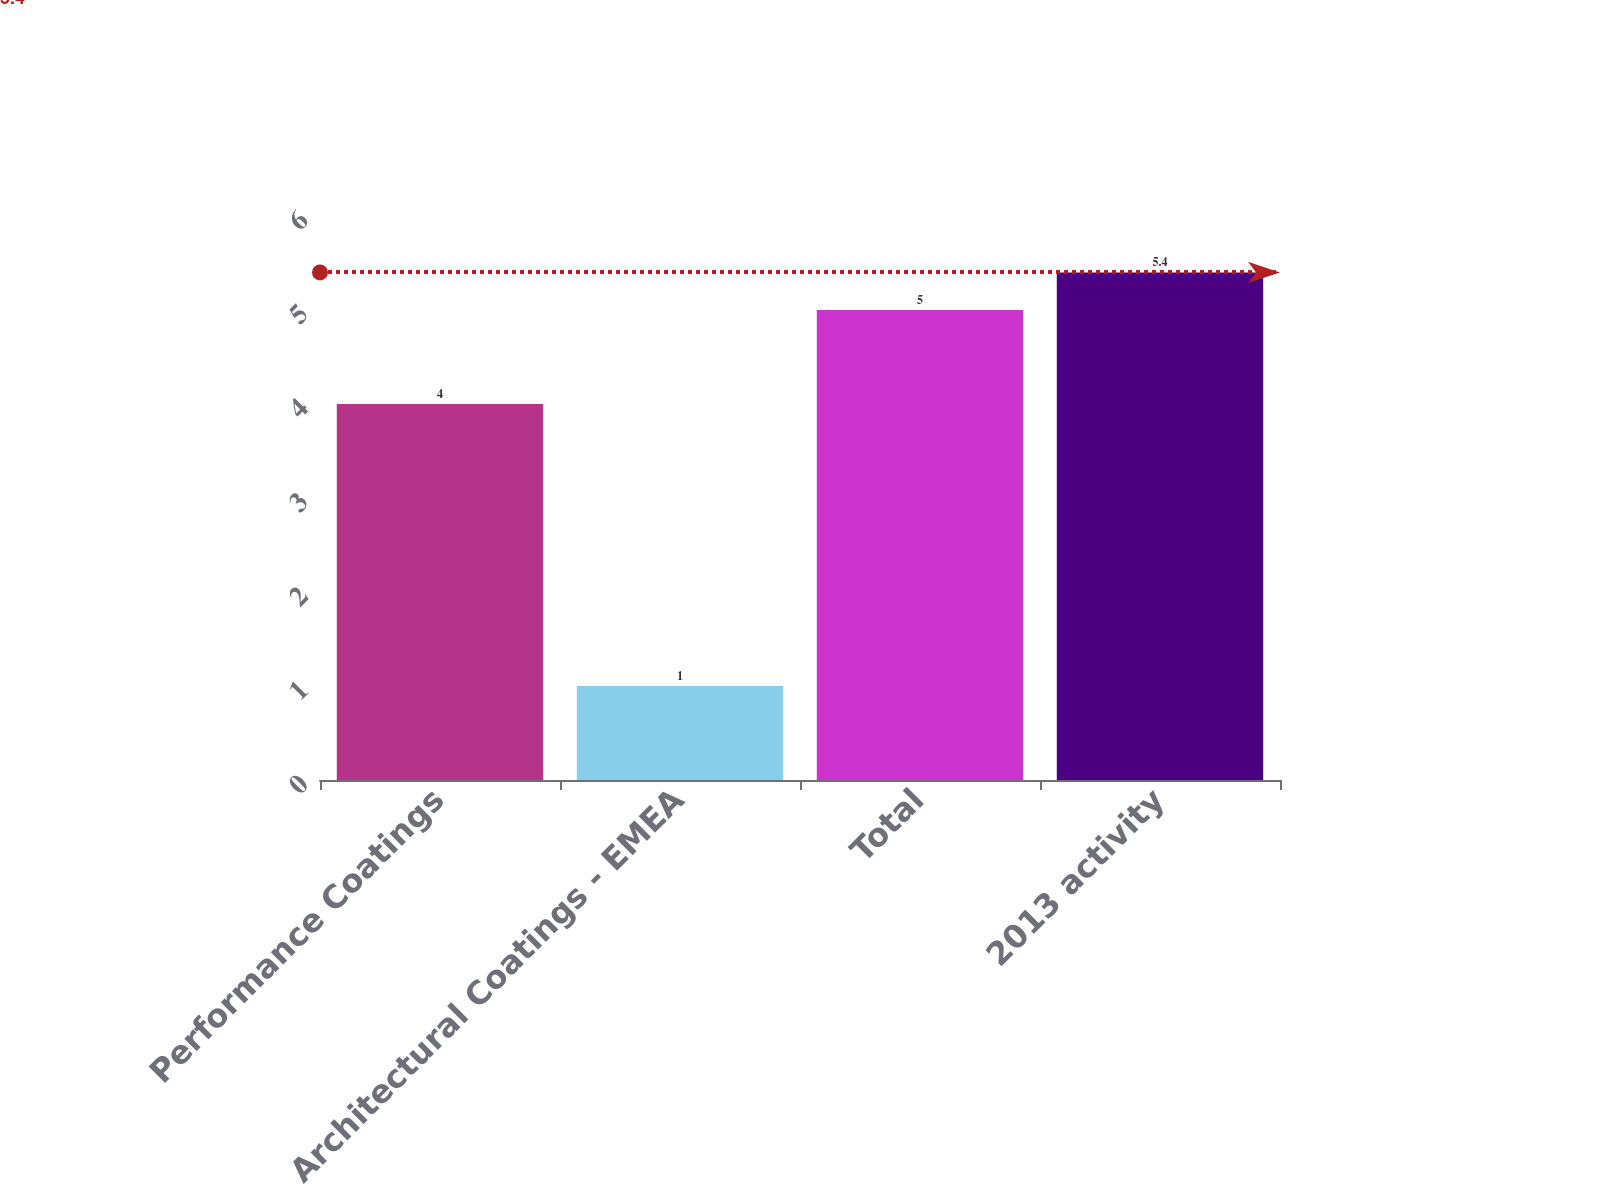Convert chart to OTSL. <chart><loc_0><loc_0><loc_500><loc_500><bar_chart><fcel>Performance Coatings<fcel>Architectural Coatings - EMEA<fcel>Total<fcel>2013 activity<nl><fcel>4<fcel>1<fcel>5<fcel>5.4<nl></chart> 